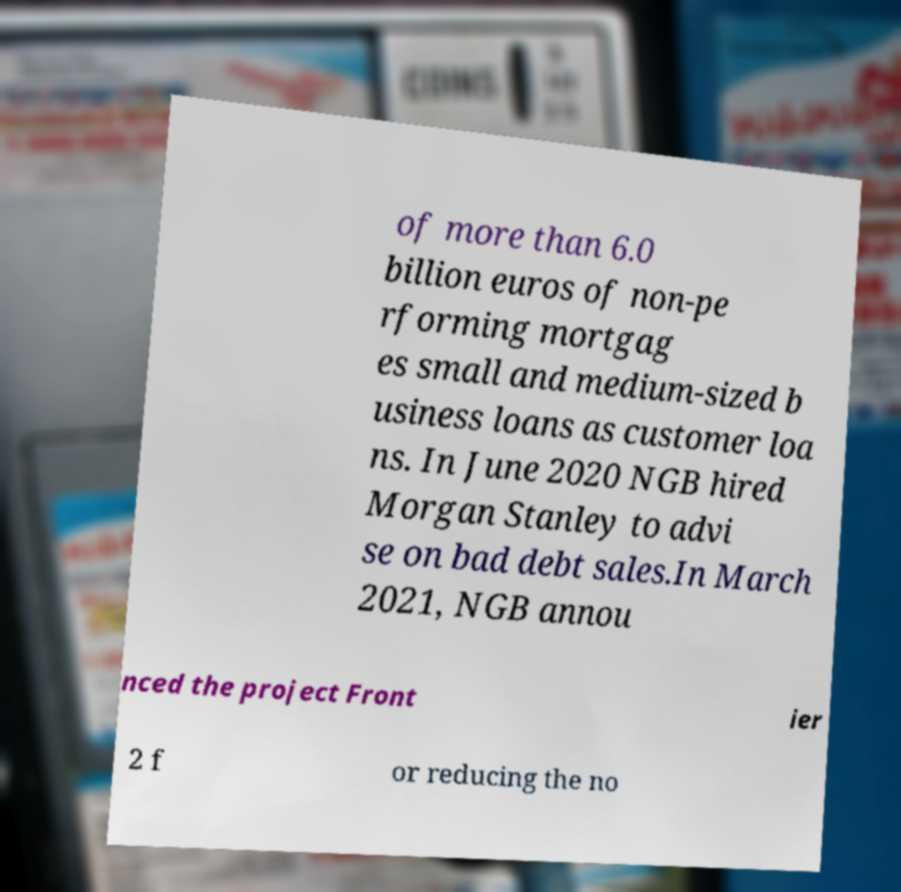Could you extract and type out the text from this image? of more than 6.0 billion euros of non-pe rforming mortgag es small and medium-sized b usiness loans as customer loa ns. In June 2020 NGB hired Morgan Stanley to advi se on bad debt sales.In March 2021, NGB annou nced the project Front ier 2 f or reducing the no 